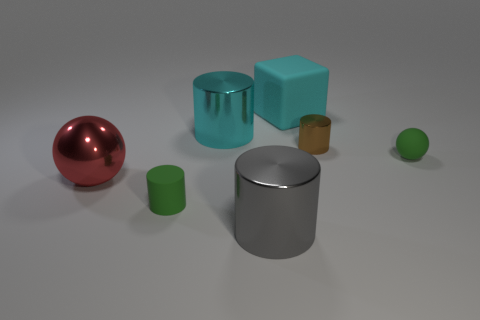What is the shape of the gray metal thing?
Make the answer very short. Cylinder. There is a object that is both behind the brown metallic cylinder and left of the large cyan cube; what is its color?
Offer a very short reply. Cyan. There is a rubber object that is the same size as the red shiny object; what is its shape?
Your response must be concise. Cube. Are there any large green rubber objects that have the same shape as the brown metal object?
Offer a terse response. No. Are the large cyan cylinder and the sphere on the left side of the gray thing made of the same material?
Your response must be concise. Yes. There is a big thing that is to the right of the large thing in front of the tiny matte thing in front of the large red metal thing; what is its color?
Provide a short and direct response. Cyan. What is the material of the block that is the same size as the red shiny thing?
Your response must be concise. Rubber. How many other brown cylinders have the same material as the brown cylinder?
Your answer should be very brief. 0. There is a green rubber object behind the large red metal object; does it have the same size as the cyan object that is left of the big block?
Your answer should be very brief. No. There is a matte thing in front of the big sphere; what is its color?
Keep it short and to the point. Green. 